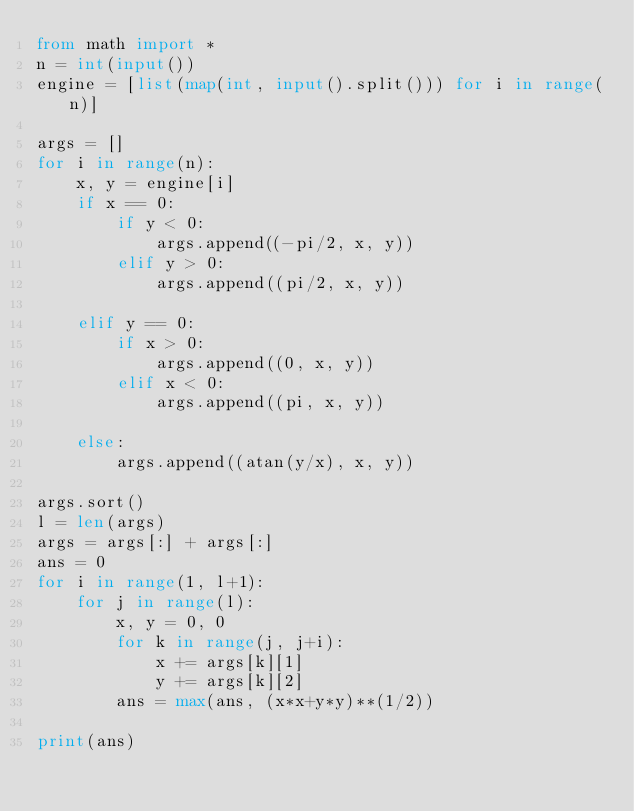<code> <loc_0><loc_0><loc_500><loc_500><_Python_>from math import *
n = int(input())
engine = [list(map(int, input().split())) for i in range(n)]

args = []
for i in range(n):
    x, y = engine[i]
    if x == 0:
        if y < 0:
            args.append((-pi/2, x, y))
        elif y > 0:
            args.append((pi/2, x, y))

    elif y == 0:
        if x > 0:
            args.append((0, x, y))
        elif x < 0:
            args.append((pi, x, y))

    else:
        args.append((atan(y/x), x, y))

args.sort()
l = len(args)
args = args[:] + args[:]
ans = 0
for i in range(1, l+1):
    for j in range(l):
        x, y = 0, 0
        for k in range(j, j+i):
            x += args[k][1]
            y += args[k][2]
        ans = max(ans, (x*x+y*y)**(1/2))

print(ans)
</code> 